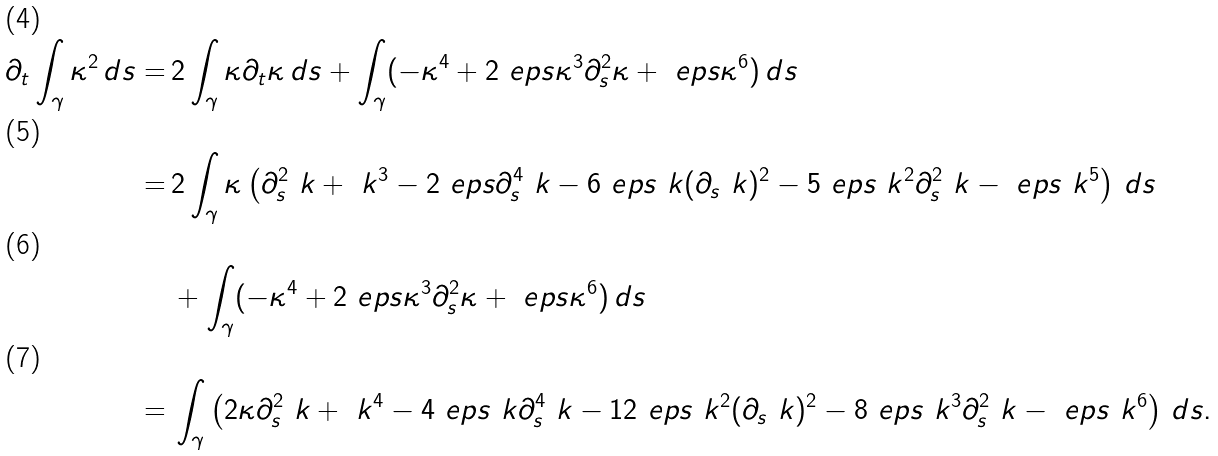<formula> <loc_0><loc_0><loc_500><loc_500>\partial _ { t } \int _ { \gamma } \kappa ^ { 2 } \, d s = & \, 2 \int _ { \gamma } \kappa \partial _ { t } \kappa \, d s + \int _ { \gamma } ( - \kappa ^ { 4 } + 2 \ e p s \kappa ^ { 3 } \partial _ { s } ^ { 2 } \kappa + \ e p s \kappa ^ { 6 } ) \, d s \\ = & \, 2 \int _ { \gamma } \kappa \left ( \partial _ { s } ^ { 2 } \ k + \ k ^ { 3 } - 2 \ e p s \partial _ { s } ^ { 4 } \ k - 6 \ e p s \ k ( \partial _ { s } \ k ) ^ { 2 } - 5 \ e p s \ k ^ { 2 } \partial ^ { 2 } _ { s } \ k - \ e p s \ k ^ { 5 } \right ) \, d s \\ & \, + \int _ { \gamma } ( - \kappa ^ { 4 } + 2 \ e p s \kappa ^ { 3 } \partial ^ { 2 } _ { s } \kappa + \ e p s \kappa ^ { 6 } ) \, d s \\ = & \, \int _ { \gamma } \left ( 2 \kappa \partial _ { s } ^ { 2 } \ k + \ k ^ { 4 } - 4 \ e p s \ k \partial _ { s } ^ { 4 } \ k - 1 2 \ e p s \ k ^ { 2 } ( \partial _ { s } \ k ) ^ { 2 } - 8 \ e p s \ k ^ { 3 } \partial ^ { 2 } _ { s } \ k - \ e p s \ k ^ { 6 } \right ) \, d s .</formula> 